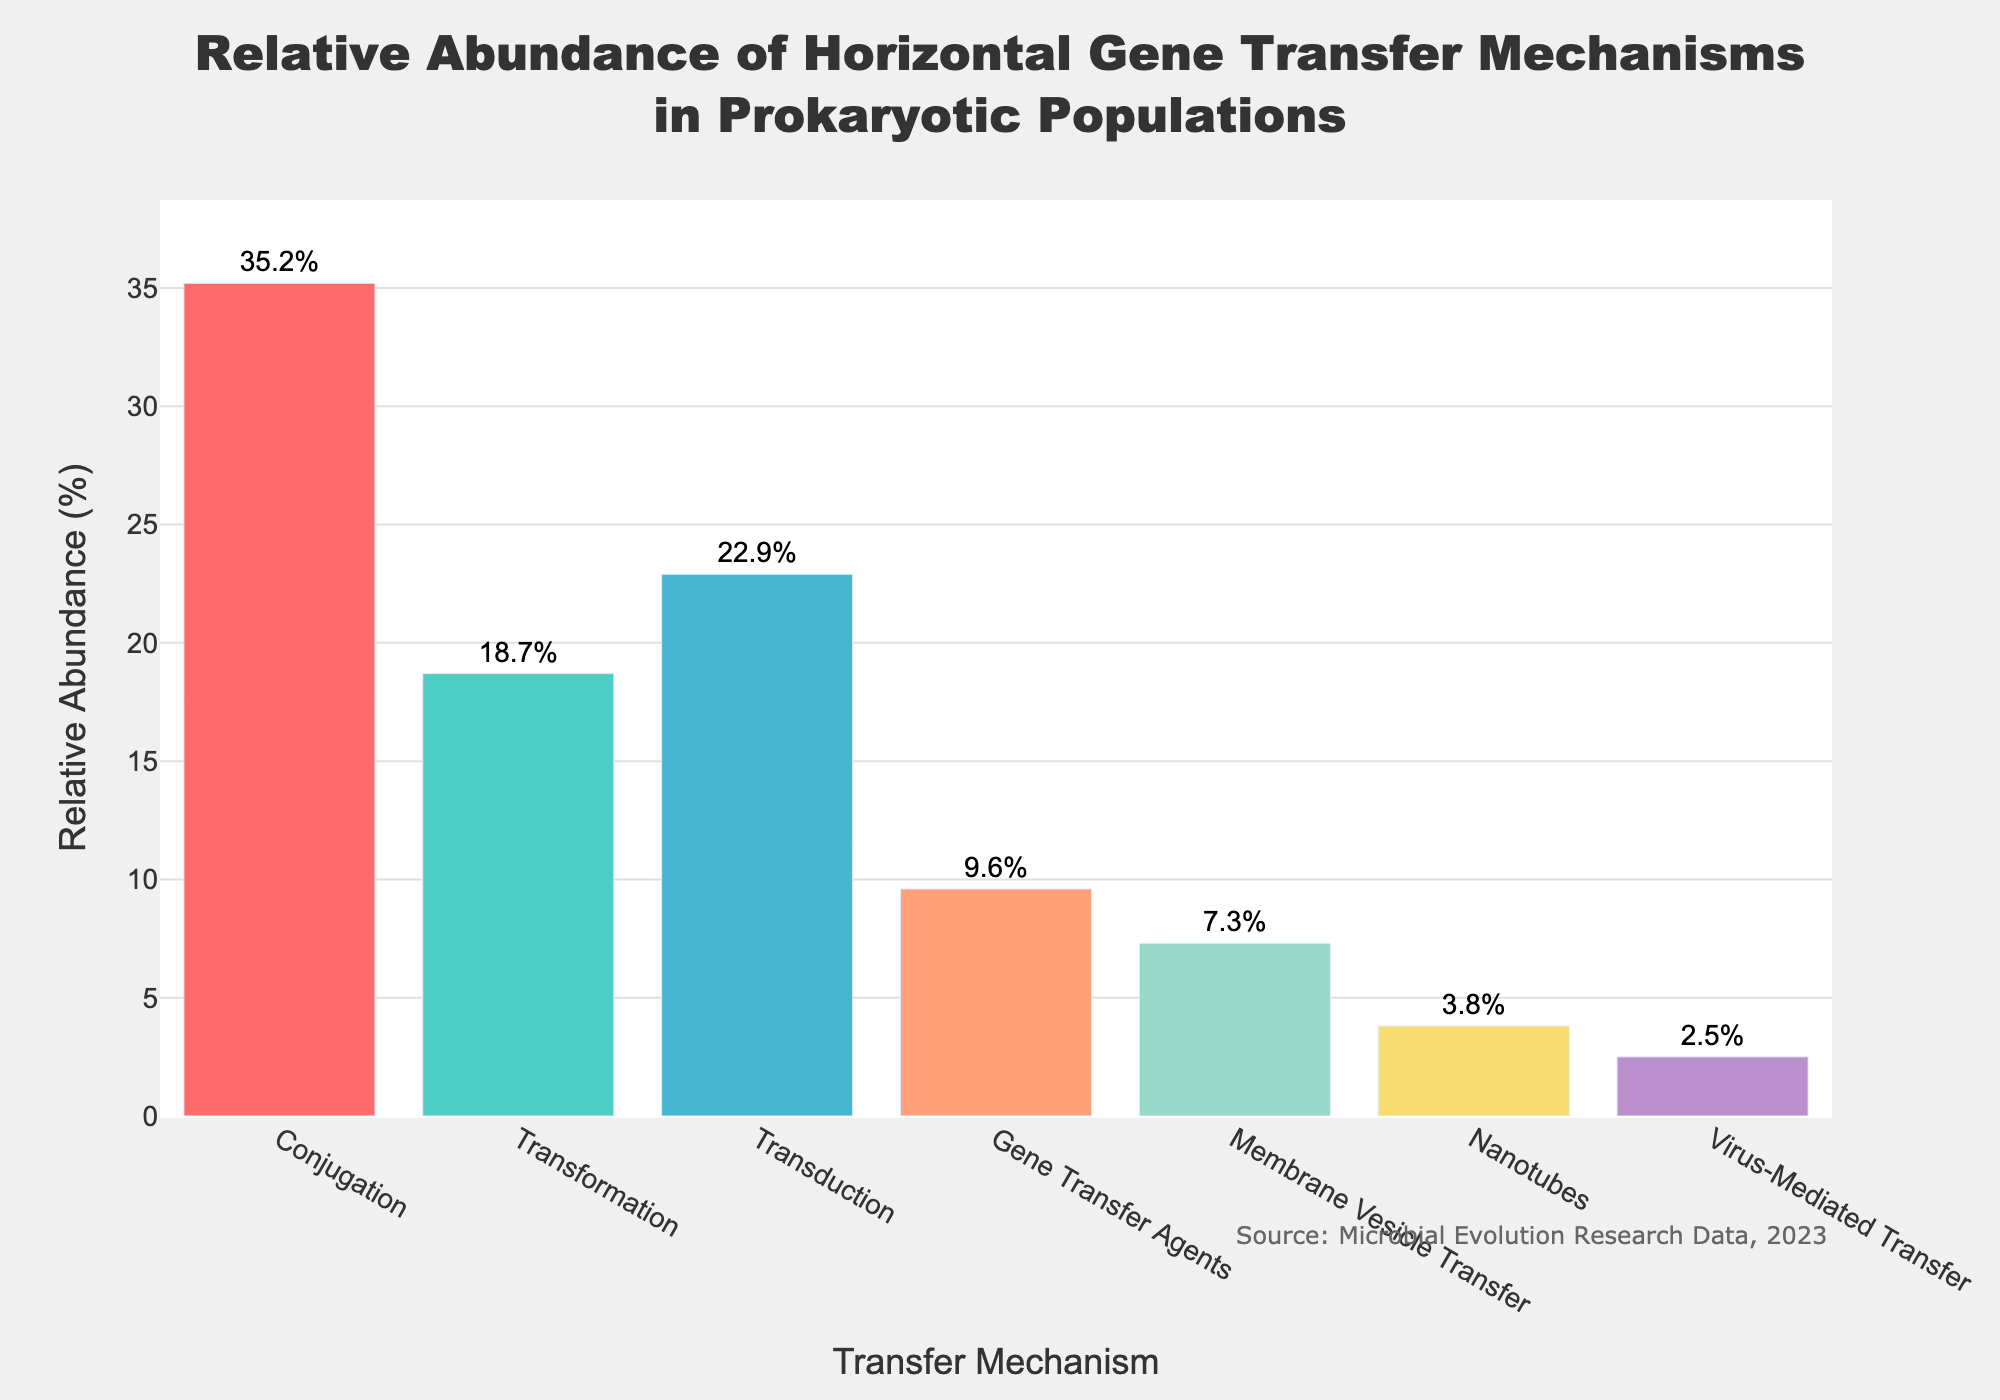What is the most common horizontal gene transfer mechanism in prokaryotic populations? To find the most common mechanism, we identify the bar with the highest value. Conjugation has the highest relative abundance of 35.2%.
Answer: Conjugation Which mechanism has the lowest relative abundance, and what is its value? To find the least common mechanism, we look for the bar with the smallest value. Virus-Mediated Transfer has the lowest relative abundance at 2.5%.
Answer: Virus-Mediated Transfer, 2.5% How much more abundant is Conjugation compared to Transduction? Calculate the difference between Conjugation's and Transduction's relative abundances. Conjugation is 35.2% and Transduction is 22.9%. The difference is 35.2 - 22.9 = 12.3%.
Answer: 12.3% What is the total relative abundance of Transformation and Gene Transfer Agents? Add the relative abundances of Transformation and Gene Transfer Agents. Transformation is 18.7% and Gene Transfer Agents is 9.6%. The total is 18.7 + 9.6 = 28.3%.
Answer: 28.3% Rank the mechanisms from highest to lowest relative abundance. Sort the mechanisms based on their relative abundance values in descending order. The order is: Conjugation (35.2%), Transduction (22.9%), Transformation (18.7%), Gene Transfer Agents (9.6%), Membrane Vesicle Transfer (7.3%), Nanotubes (3.8%), Virus-Mediated Transfer (2.5%).
Answer: Conjugation, Transduction, Transformation, Gene Transfer Agents, Membrane Vesicle Transfer, Nanotubes, Virus-Mediated Transfer Which mechanism has a relative abundance closest to 10%? Compare each mechanism's relative abundance to 10% and find the closest value. Gene Transfer Agents have a relative abundance of 9.6%, which is closest to 10%.
Answer: Gene Transfer Agents What is the combined relative abundance of the mechanisms that have less than 10% relative abundance individually? Sum the relative abundances of Nanotubes (3.8%) and Virus-Mediated Transfer (2.5%). The combined total is 3.8 + 2.5 = 6.3%.
Answer: 6.3% How much more abundant are Conjugation and Transduction together compared to Transformation and Membrane Vesicle Transfer together? Calculate the total relative abundance of Conjugation (35.2%) and Transduction (22.9%), which is 35.2 + 22.9 = 58.1%. Then, calculate the total for Transformation (18.7%) and Membrane Vesicle Transfer (7.3%), which is 18.7 + 7.3 = 26.0%. The difference is 58.1 - 26.0 = 32.1%.
Answer: 32.1% Which mechanism is represented by the blue bar? Examine the distinct colors used in the bar chart. Transformation is represented by the blue bar.
Answer: Transformation If Nanotubes and Virus-Mediated Transfer were combined into one category, what would be the new relative abundance? Add the relative abundances of Nanotubes (3.8%) and Virus-Mediated Transfer (2.5%). The new combined relative abundance is 3.8 + 2.5 = 6.3%.
Answer: 6.3% 